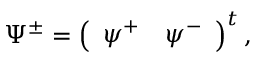Convert formula to latex. <formula><loc_0><loc_0><loc_500><loc_500>\Psi ^ { \pm } = \left ( \begin{array} { r r } { { \psi ^ { + } } } & { { \psi ^ { - } } } \end{array} \right ) ^ { t } ,</formula> 